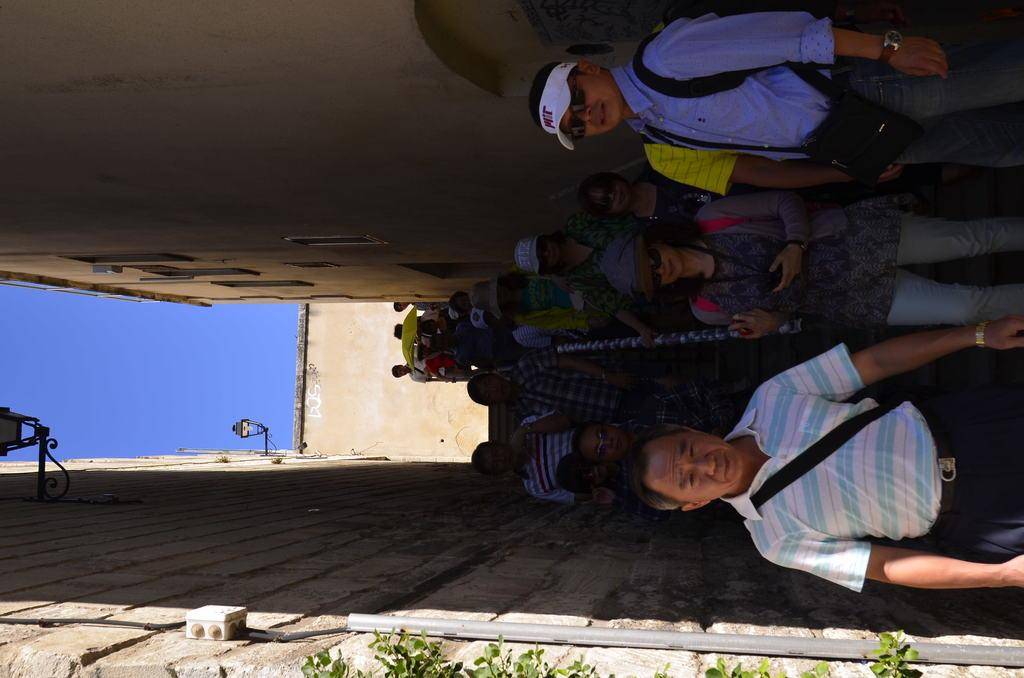How is the image oriented? The image is tilted. What can be seen on the walls in the image? There is a wall in the image. What type of lighting is present in the image? There are skylights in the image. What type of vegetation is visible in the image? Green leaves are visible in the image. Who or what is present in the image? There are people in the image. What architectural feature is present in the image? There are stairs in the image. What object can be seen in the image that resembles a long, thin bar? There is a rod in the image. What type of cable is being used by the coach in the image? There is no coach or cable present in the image. 